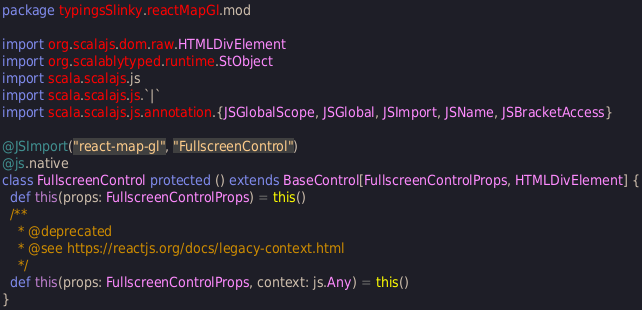Convert code to text. <code><loc_0><loc_0><loc_500><loc_500><_Scala_>package typingsSlinky.reactMapGl.mod

import org.scalajs.dom.raw.HTMLDivElement
import org.scalablytyped.runtime.StObject
import scala.scalajs.js
import scala.scalajs.js.`|`
import scala.scalajs.js.annotation.{JSGlobalScope, JSGlobal, JSImport, JSName, JSBracketAccess}

@JSImport("react-map-gl", "FullscreenControl")
@js.native
class FullscreenControl protected () extends BaseControl[FullscreenControlProps, HTMLDivElement] {
  def this(props: FullscreenControlProps) = this()
  /**
    * @deprecated
    * @see https://reactjs.org/docs/legacy-context.html
    */
  def this(props: FullscreenControlProps, context: js.Any) = this()
}
</code> 